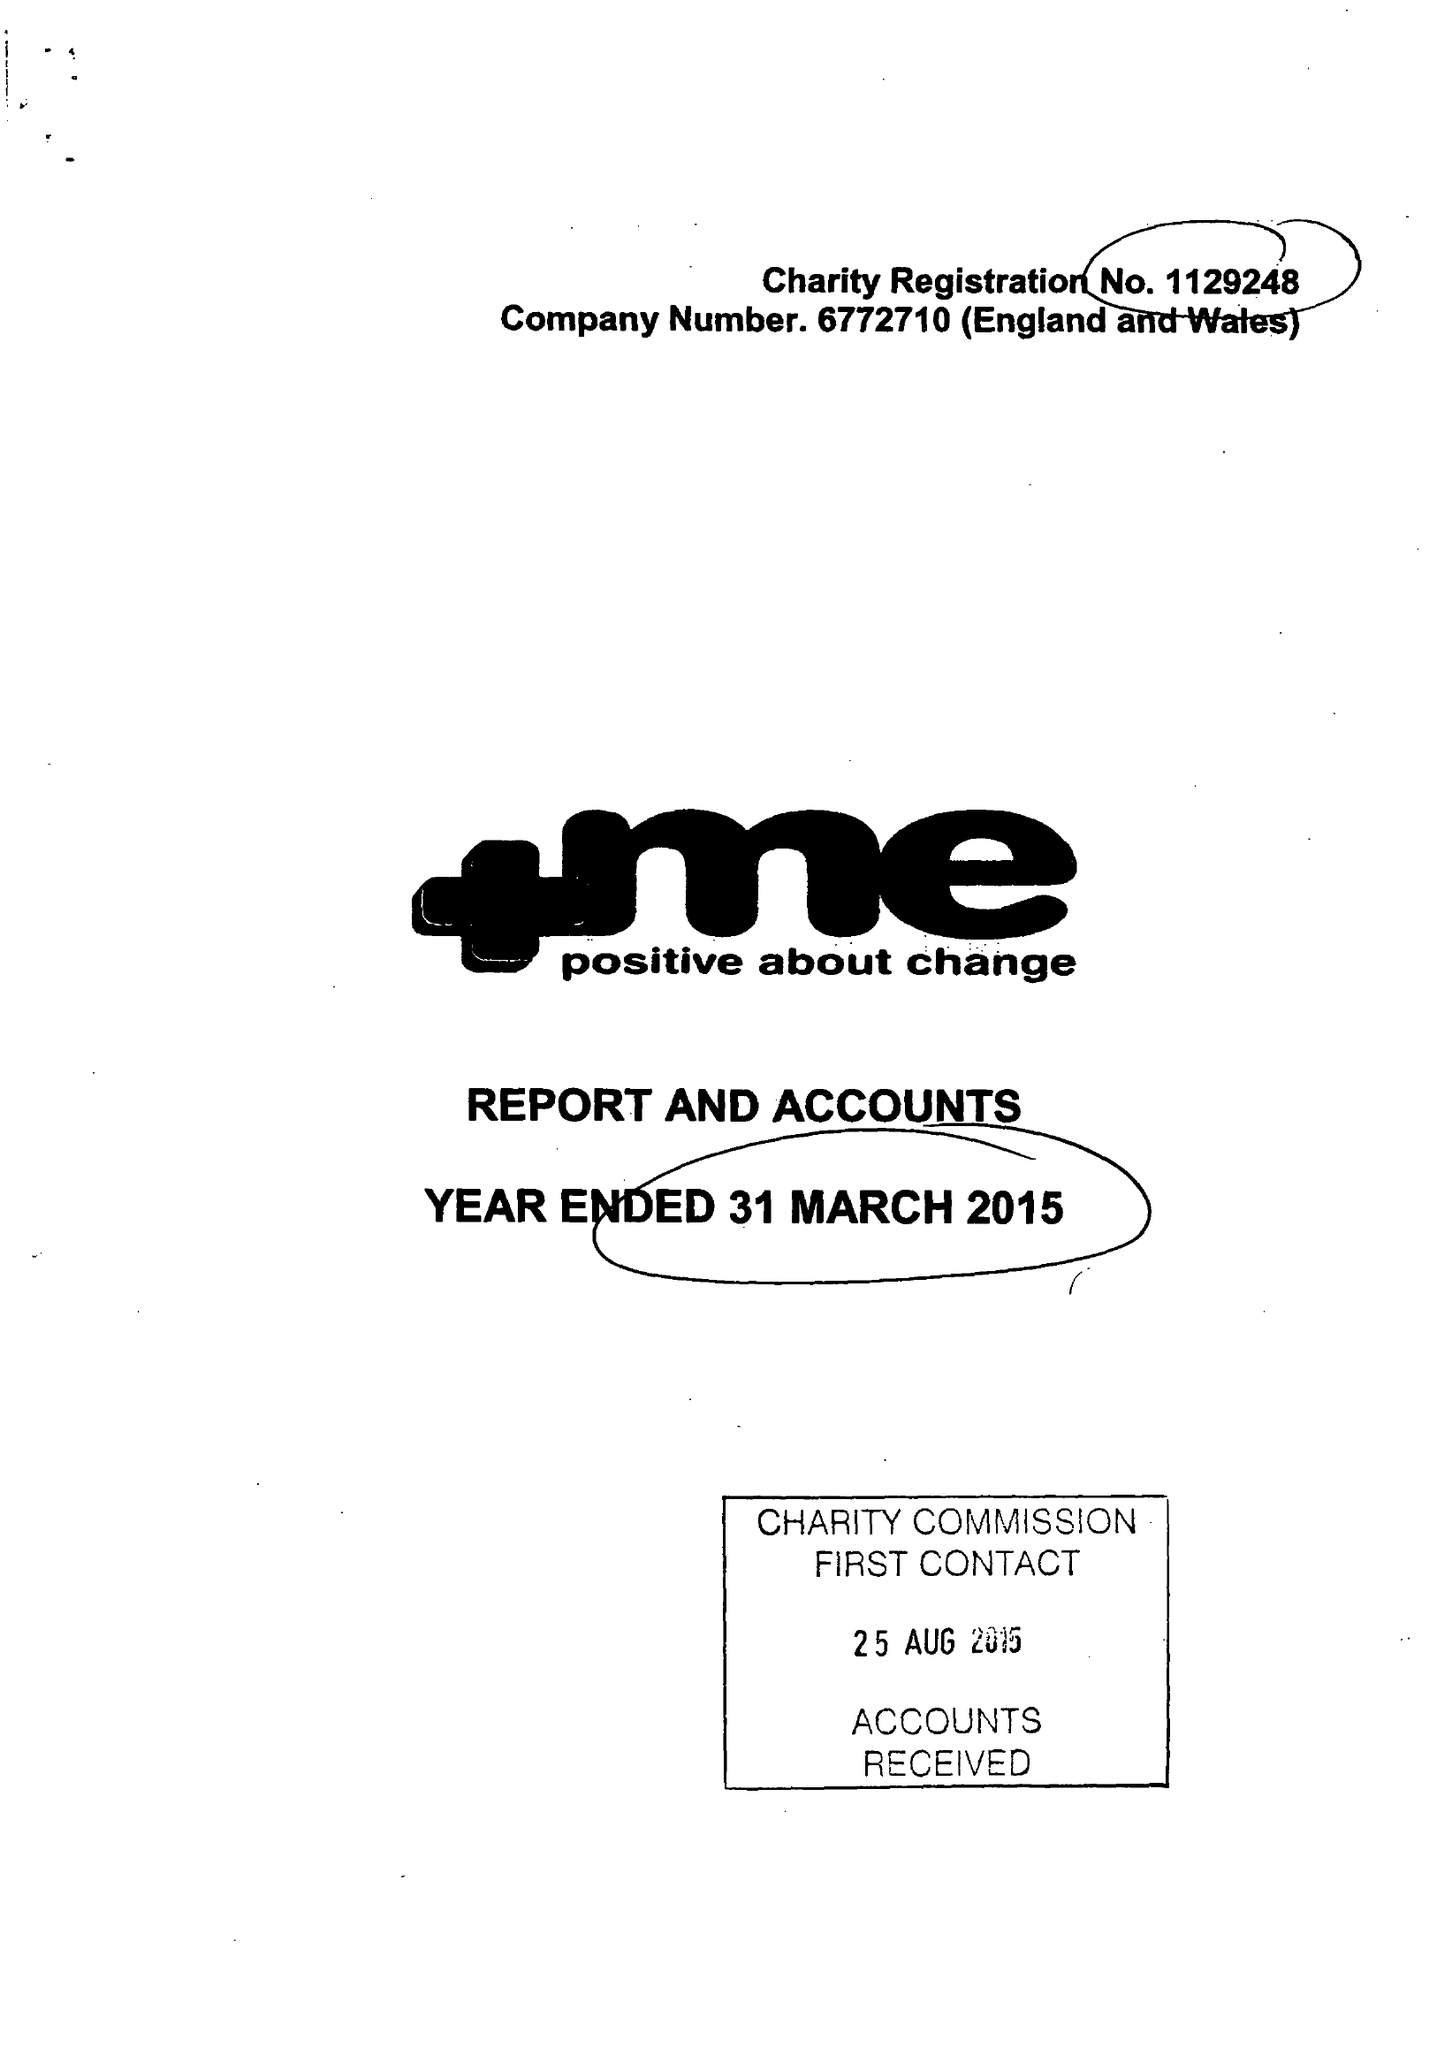What is the value for the charity_number?
Answer the question using a single word or phrase. 1129248 